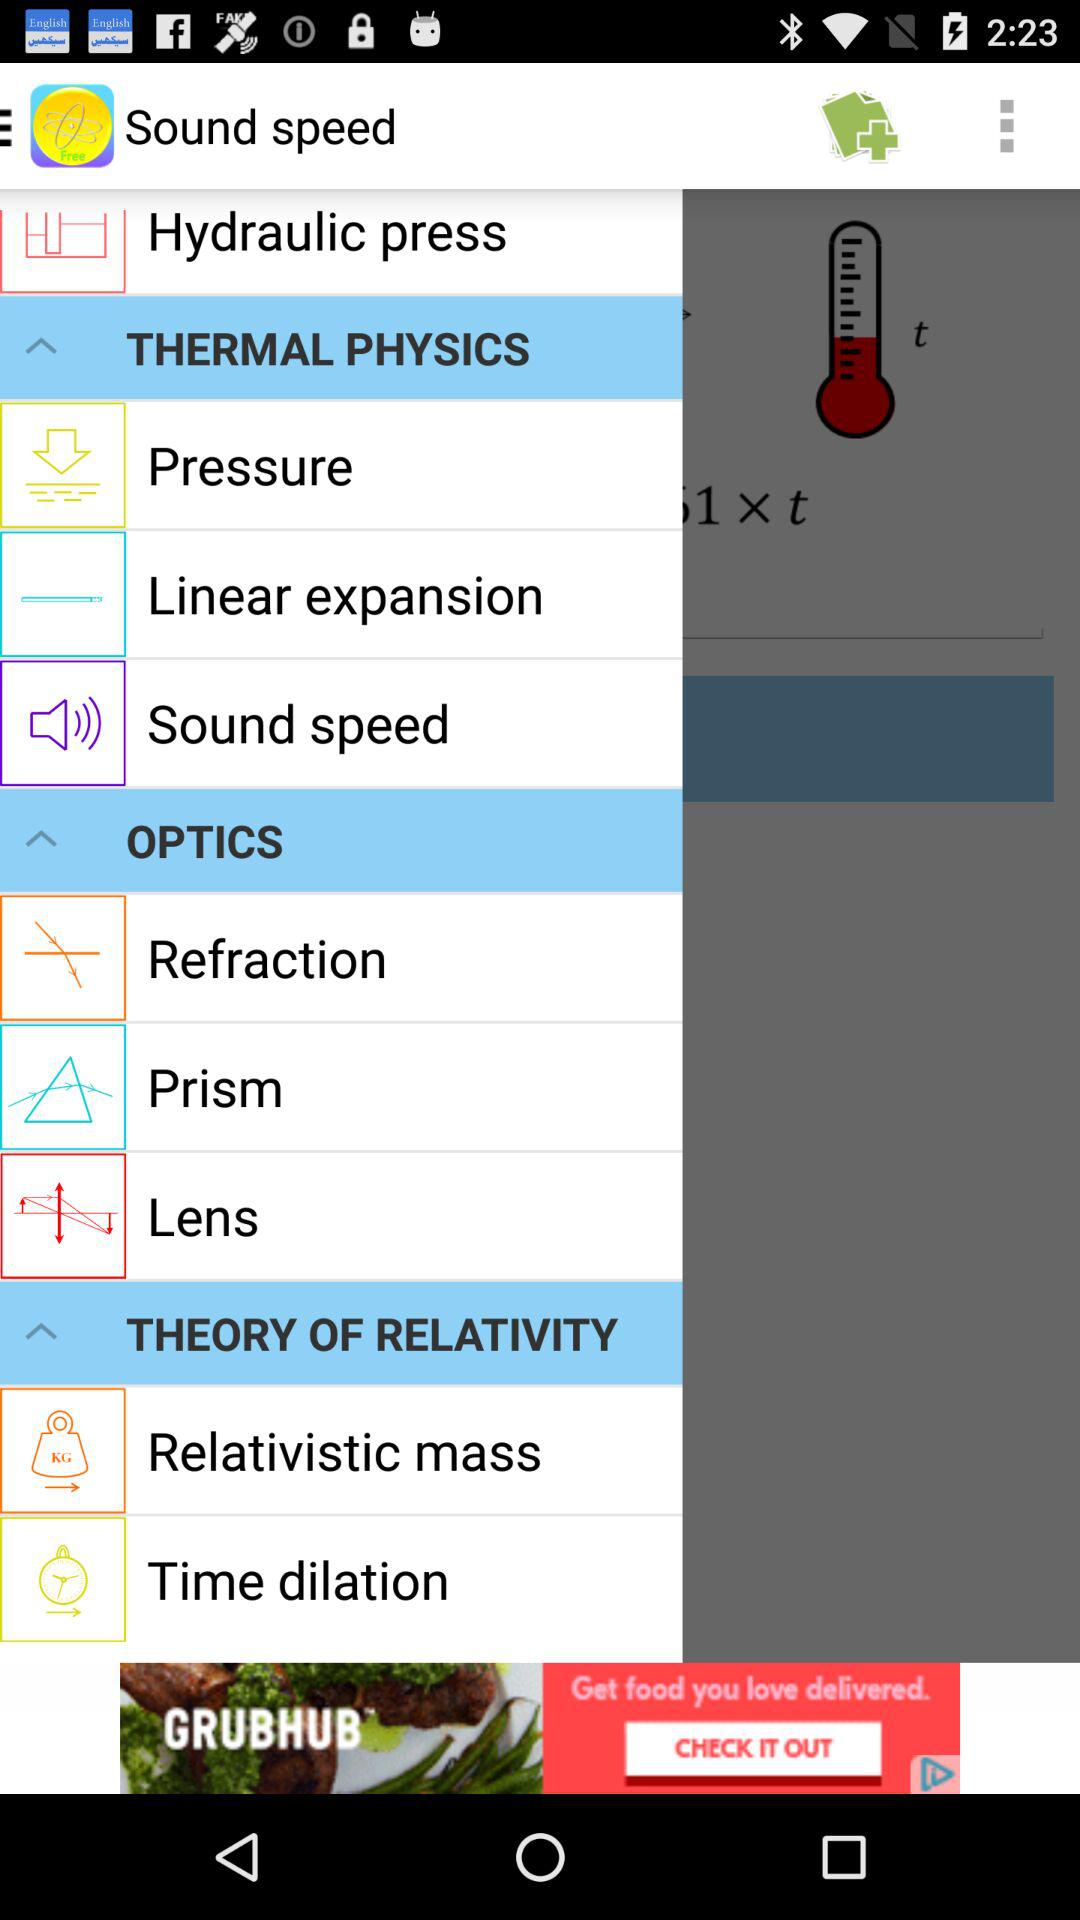What is the application name? The application name is "Sound speed". 